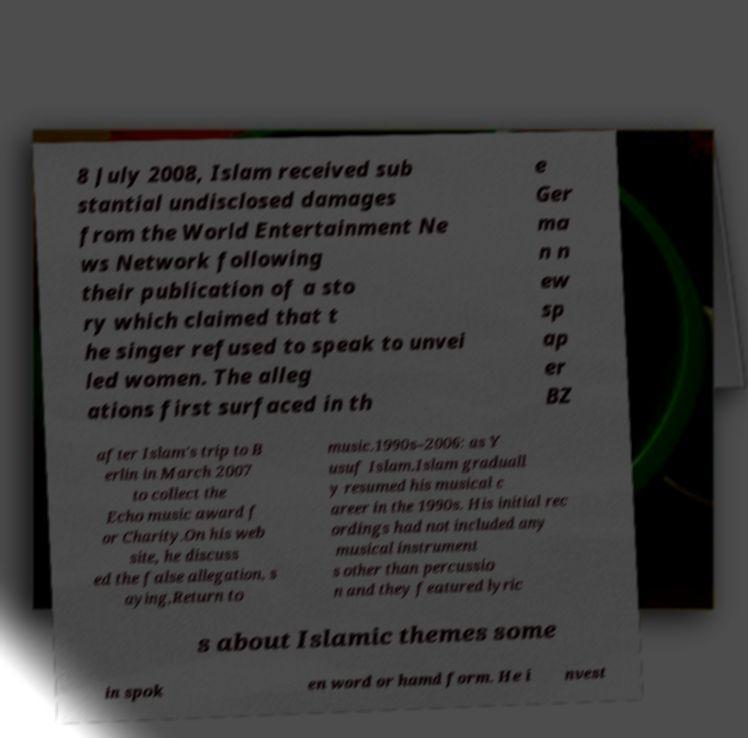What messages or text are displayed in this image? I need them in a readable, typed format. 8 July 2008, Islam received sub stantial undisclosed damages from the World Entertainment Ne ws Network following their publication of a sto ry which claimed that t he singer refused to speak to unvei led women. The alleg ations first surfaced in th e Ger ma n n ew sp ap er BZ after Islam's trip to B erlin in March 2007 to collect the Echo music award f or Charity.On his web site, he discuss ed the false allegation, s aying,Return to music.1990s–2006: as Y usuf Islam.Islam graduall y resumed his musical c areer in the 1990s. His initial rec ordings had not included any musical instrument s other than percussio n and they featured lyric s about Islamic themes some in spok en word or hamd form. He i nvest 